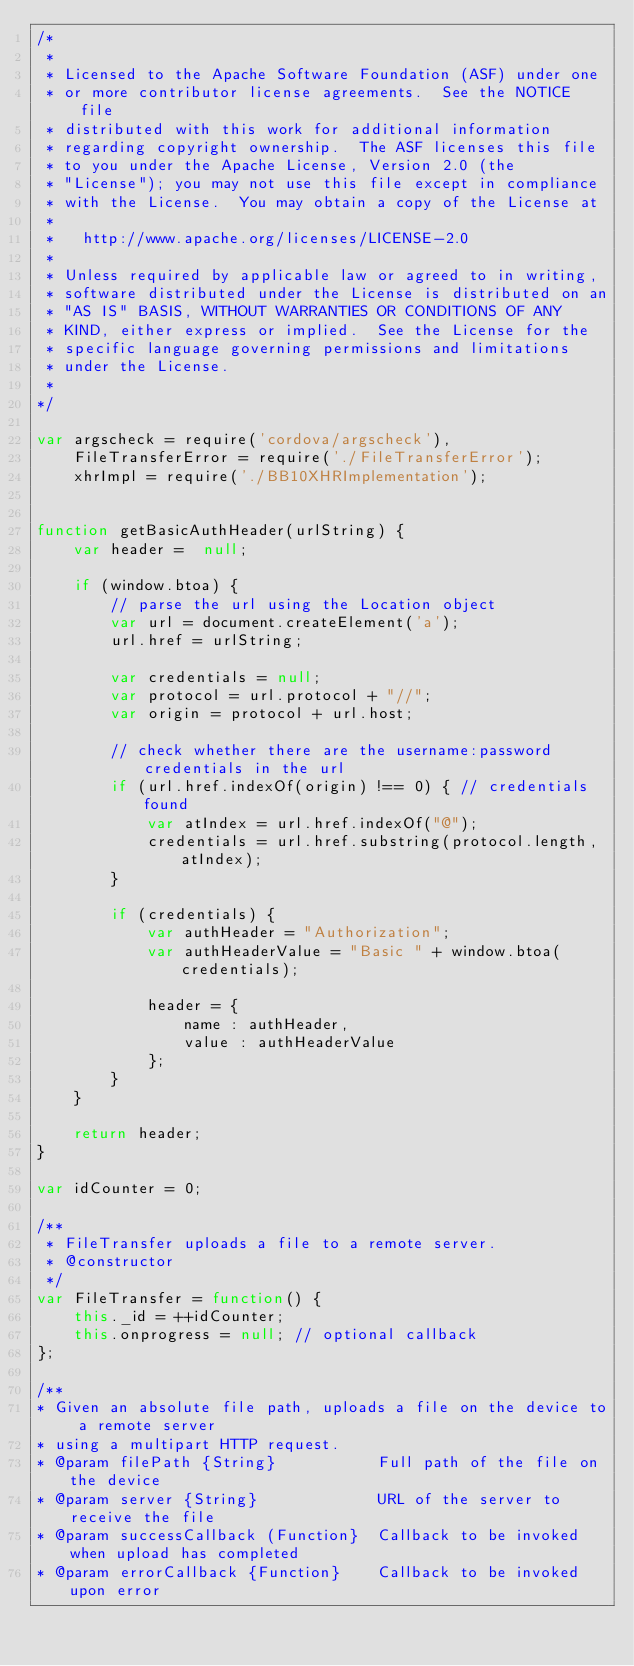<code> <loc_0><loc_0><loc_500><loc_500><_JavaScript_>/*
 *
 * Licensed to the Apache Software Foundation (ASF) under one
 * or more contributor license agreements.  See the NOTICE file
 * distributed with this work for additional information
 * regarding copyright ownership.  The ASF licenses this file
 * to you under the Apache License, Version 2.0 (the
 * "License"); you may not use this file except in compliance
 * with the License.  You may obtain a copy of the License at
 *
 *   http://www.apache.org/licenses/LICENSE-2.0
 *
 * Unless required by applicable law or agreed to in writing,
 * software distributed under the License is distributed on an
 * "AS IS" BASIS, WITHOUT WARRANTIES OR CONDITIONS OF ANY
 * KIND, either express or implied.  See the License for the
 * specific language governing permissions and limitations
 * under the License.
 *
*/

var argscheck = require('cordova/argscheck'),
    FileTransferError = require('./FileTransferError');
    xhrImpl = require('./BB10XHRImplementation');


function getBasicAuthHeader(urlString) {
    var header =  null;

    if (window.btoa) {
        // parse the url using the Location object
        var url = document.createElement('a');
        url.href = urlString;

        var credentials = null;
        var protocol = url.protocol + "//";
        var origin = protocol + url.host;

        // check whether there are the username:password credentials in the url
        if (url.href.indexOf(origin) !== 0) { // credentials found
            var atIndex = url.href.indexOf("@");
            credentials = url.href.substring(protocol.length, atIndex);
        }

        if (credentials) {
            var authHeader = "Authorization";
            var authHeaderValue = "Basic " + window.btoa(credentials);

            header = {
                name : authHeader,
                value : authHeaderValue
            };
        }
    }

    return header;
}

var idCounter = 0;

/**
 * FileTransfer uploads a file to a remote server.
 * @constructor
 */
var FileTransfer = function() {
    this._id = ++idCounter;
    this.onprogress = null; // optional callback
};

/**
* Given an absolute file path, uploads a file on the device to a remote server
* using a multipart HTTP request.
* @param filePath {String}           Full path of the file on the device
* @param server {String}             URL of the server to receive the file
* @param successCallback (Function}  Callback to be invoked when upload has completed
* @param errorCallback {Function}    Callback to be invoked upon error</code> 